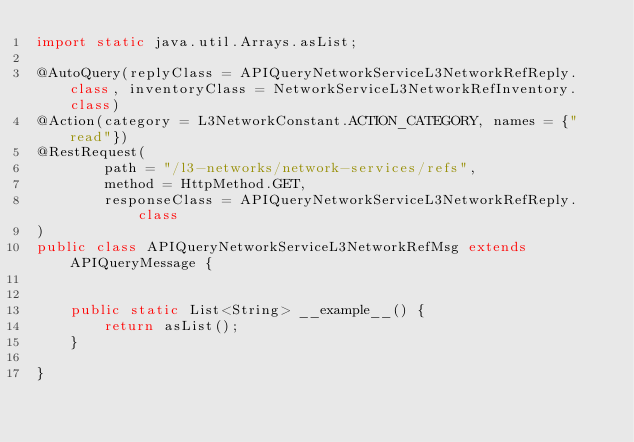<code> <loc_0><loc_0><loc_500><loc_500><_Java_>import static java.util.Arrays.asList;

@AutoQuery(replyClass = APIQueryNetworkServiceL3NetworkRefReply.class, inventoryClass = NetworkServiceL3NetworkRefInventory.class)
@Action(category = L3NetworkConstant.ACTION_CATEGORY, names = {"read"})
@RestRequest(
        path = "/l3-networks/network-services/refs",
        method = HttpMethod.GET,
        responseClass = APIQueryNetworkServiceL3NetworkRefReply.class
)
public class APIQueryNetworkServiceL3NetworkRefMsg extends APIQueryMessage {


    public static List<String> __example__() {
        return asList();
    }

}
</code> 